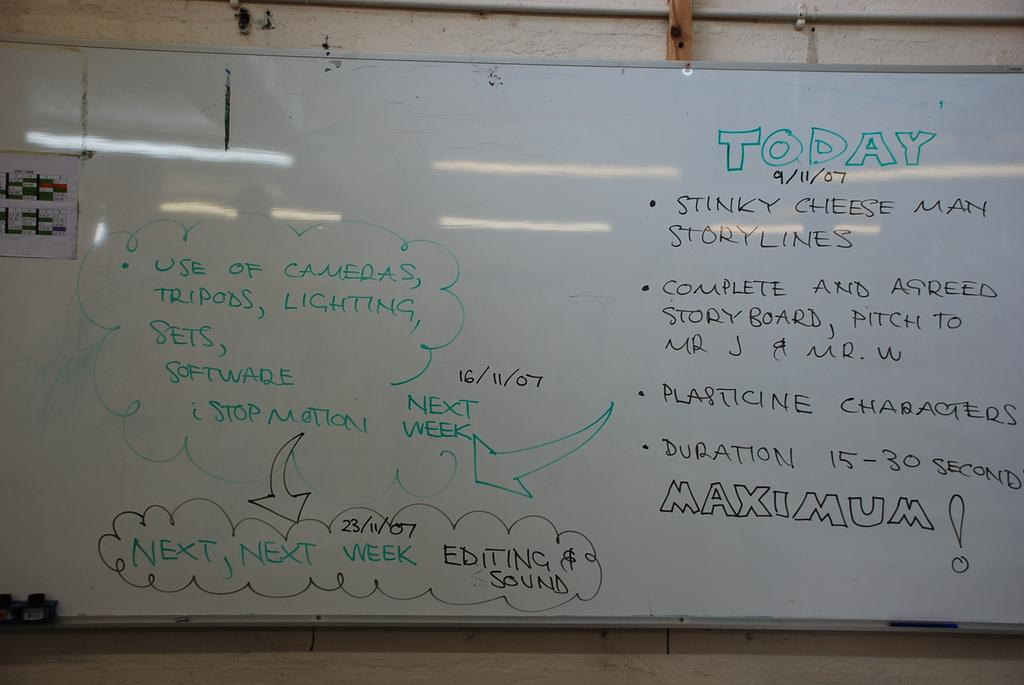<image>
Relay a brief, clear account of the picture shown. A dry erase board with the planning for Today, 9/11/07, including different story lines and characters development. 